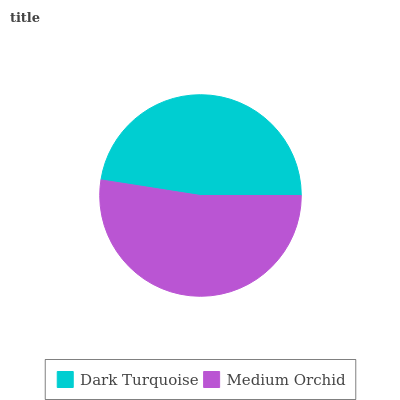Is Dark Turquoise the minimum?
Answer yes or no. Yes. Is Medium Orchid the maximum?
Answer yes or no. Yes. Is Medium Orchid the minimum?
Answer yes or no. No. Is Medium Orchid greater than Dark Turquoise?
Answer yes or no. Yes. Is Dark Turquoise less than Medium Orchid?
Answer yes or no. Yes. Is Dark Turquoise greater than Medium Orchid?
Answer yes or no. No. Is Medium Orchid less than Dark Turquoise?
Answer yes or no. No. Is Medium Orchid the high median?
Answer yes or no. Yes. Is Dark Turquoise the low median?
Answer yes or no. Yes. Is Dark Turquoise the high median?
Answer yes or no. No. Is Medium Orchid the low median?
Answer yes or no. No. 